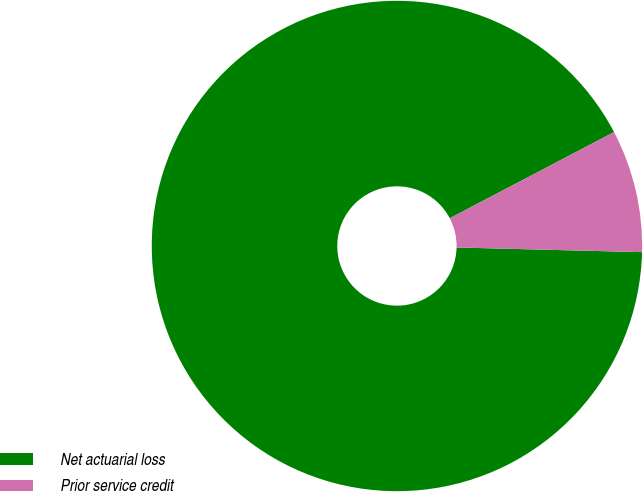<chart> <loc_0><loc_0><loc_500><loc_500><pie_chart><fcel>Net actuarial loss<fcel>Prior service credit<nl><fcel>91.91%<fcel>8.09%<nl></chart> 